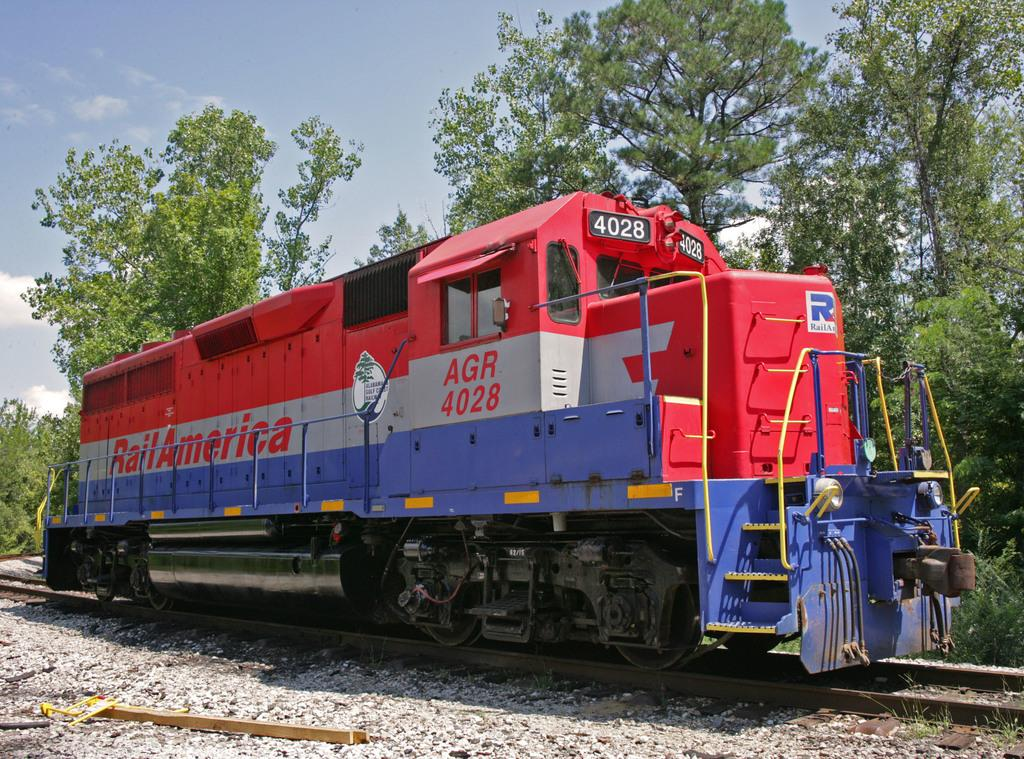What is the main subject of the image? The main subject of the image is a train. What is the train doing in the image? The train is moving on rail tracks. What type of natural environment can be seen in the image? There are trees visible in the image. What is visible in the background of the image? The sky is visible in the image. What type of bird can be seen singing a story in the image? There is no bird or storytelling activity present in the image; it features a moving train on rail tracks with trees and the sky visible in the background. 